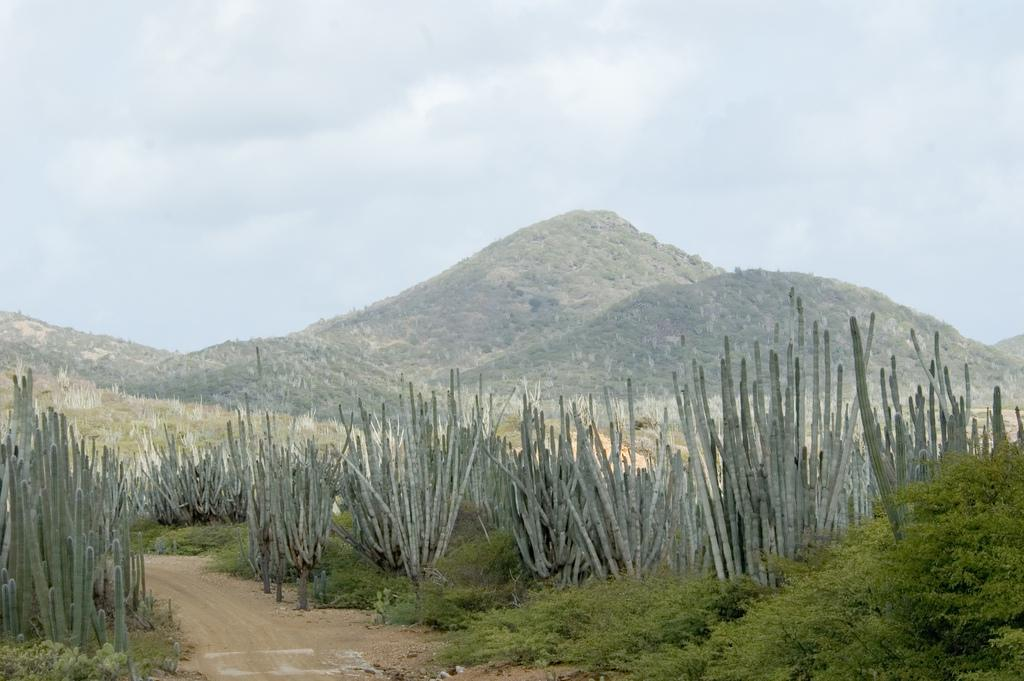What type of living organisms can be seen in the image? Plants can be seen in the image. What natural features are visible in the background of the image? Mountains and the sky are visible in the background of the image. How many goldfish can be seen swimming in the image? There are no goldfish present in the image. Is there a carpenter working on a project in the image? There is no carpenter or any indication of a project being worked on in the image. 